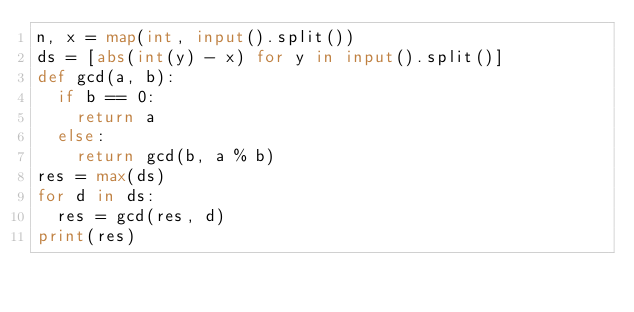<code> <loc_0><loc_0><loc_500><loc_500><_Python_>n, x = map(int, input().split())
ds = [abs(int(y) - x) for y in input().split()]
def gcd(a, b):
  if b == 0:
    return a
  else:
    return gcd(b, a % b)
res = max(ds) 
for d in ds:
  res = gcd(res, d)
print(res)</code> 